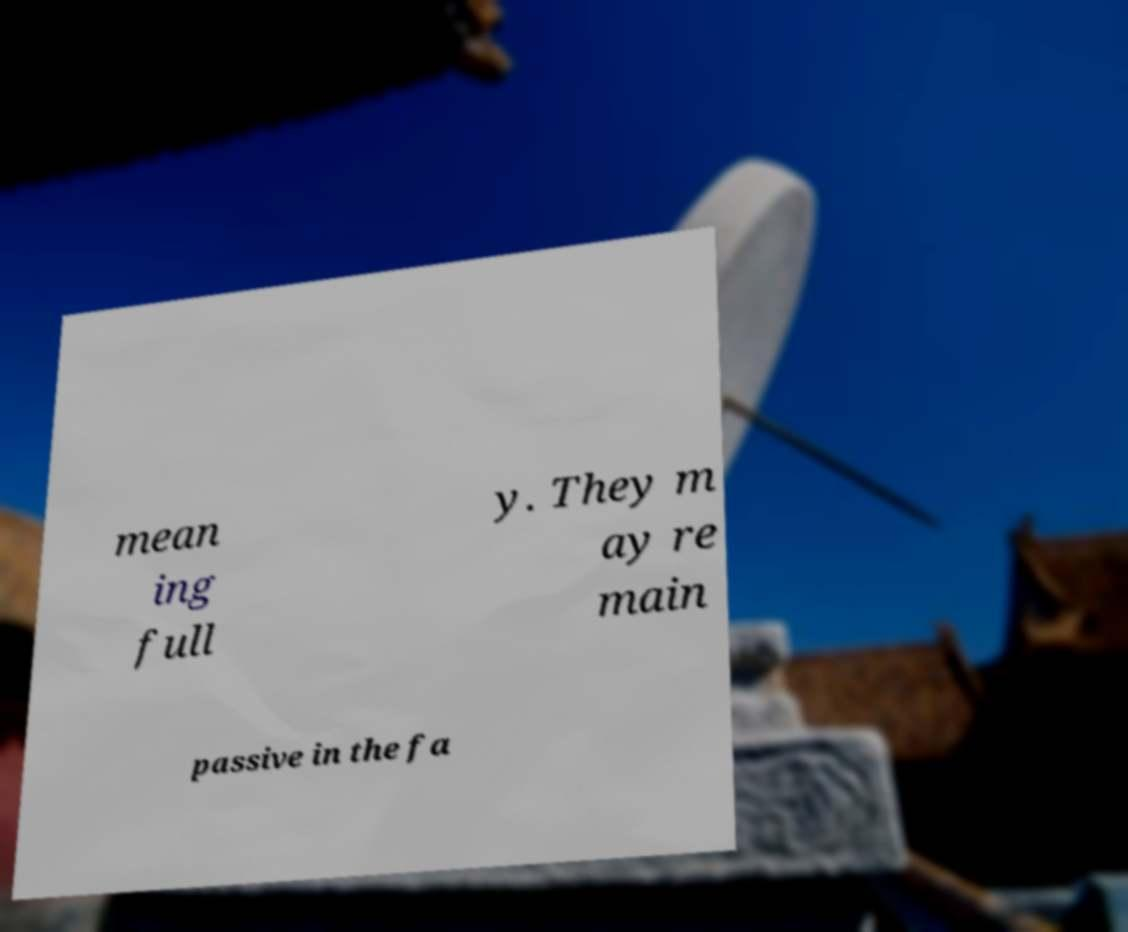Could you assist in decoding the text presented in this image and type it out clearly? mean ing full y. They m ay re main passive in the fa 